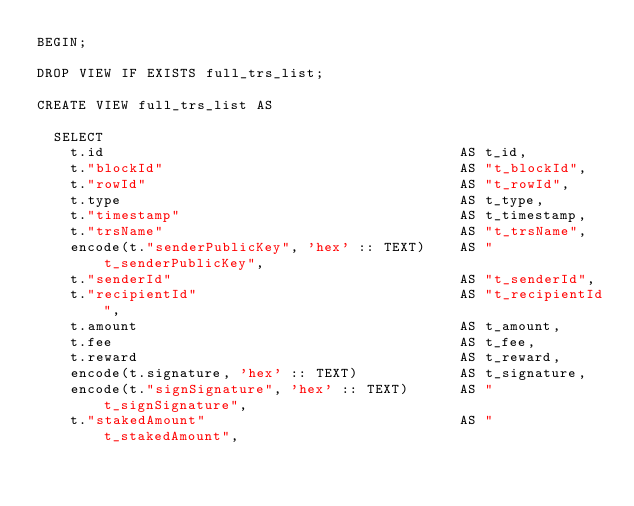<code> <loc_0><loc_0><loc_500><loc_500><_SQL_>BEGIN;

DROP VIEW IF EXISTS full_trs_list;

CREATE VIEW full_trs_list AS

  SELECT
    t.id                                          AS t_id,
    t."blockId"                                   AS "t_blockId",
    t."rowId"                                     AS "t_rowId",
    t.type                                        AS t_type,
    t."timestamp"                                 AS t_timestamp,
    t."trsName"                                   AS "t_trsName",
    encode(t."senderPublicKey", 'hex' :: TEXT)    AS "t_senderPublicKey",
    t."senderId"                                  AS "t_senderId",
    t."recipientId"                               AS "t_recipientId",
    t.amount                                      AS t_amount,
    t.fee                                         AS t_fee,
    t.reward                                      AS t_reward,
    encode(t.signature, 'hex' :: TEXT)            AS t_signature,
    encode(t."signSignature", 'hex' :: TEXT)      AS "t_signSignature",
    t."stakedAmount"                              AS "t_stakedAmount",</code> 